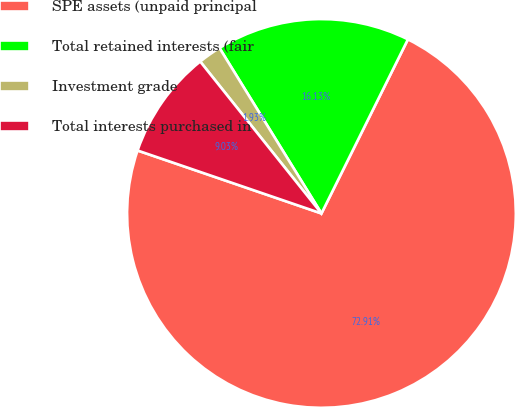Convert chart. <chart><loc_0><loc_0><loc_500><loc_500><pie_chart><fcel>SPE assets (unpaid principal<fcel>Total retained interests (fair<fcel>Investment grade<fcel>Total interests purchased in<nl><fcel>72.92%<fcel>16.13%<fcel>1.93%<fcel>9.03%<nl></chart> 